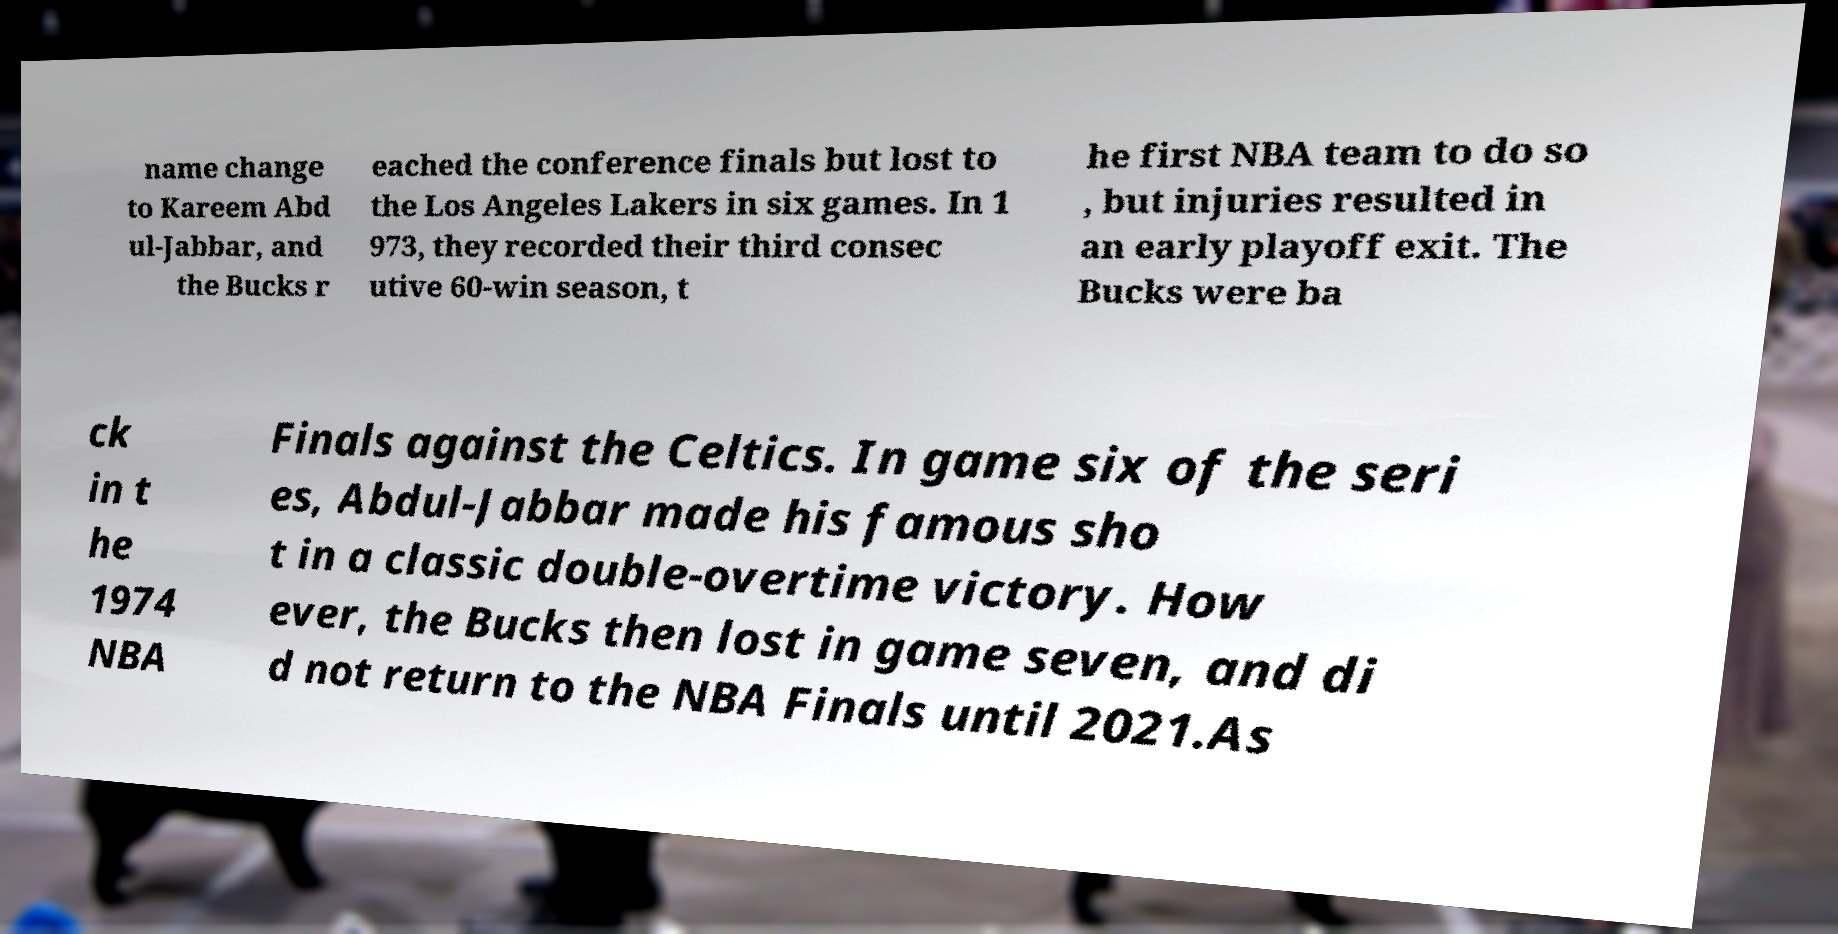Can you read and provide the text displayed in the image?This photo seems to have some interesting text. Can you extract and type it out for me? name change to Kareem Abd ul-Jabbar, and the Bucks r eached the conference finals but lost to the Los Angeles Lakers in six games. In 1 973, they recorded their third consec utive 60-win season, t he first NBA team to do so , but injuries resulted in an early playoff exit. The Bucks were ba ck in t he 1974 NBA Finals against the Celtics. In game six of the seri es, Abdul-Jabbar made his famous sho t in a classic double-overtime victory. How ever, the Bucks then lost in game seven, and di d not return to the NBA Finals until 2021.As 